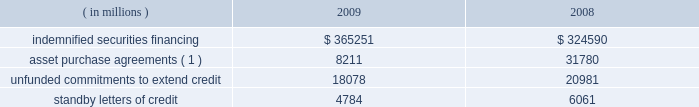Note 10 .
Commitments and contingencies credit-related commitments and contingencies : credit-related financial instruments , which are off-balance sheet , include indemnified securities financing , unfunded commitments to extend credit or purchase assets , and standby letters of credit .
The potential loss associated with indemnified securities financing , unfunded commitments and standby letters of credit is equal to the total gross contractual amount , which does not consider the value of any collateral .
The table summarizes the total gross contractual amounts of credit-related off-balance sheet financial instruments at december 31 .
Amounts reported do not reflect participations to independent third parties. .
( 1 ) amount for 2009 excludes agreements related to the commercial paper conduits , which were consolidated in may 2009 ; see note 11 .
Approximately 81% ( 81 % ) of the unfunded commitments to extend credit expire within one year from the date of issue .
Since many of these commitments are expected to expire or renew without being drawn upon , the total commitment amount does not necessarily represent future cash requirements .
Securities finance : on behalf of our customers , we lend their securities to creditworthy brokers and other institutions .
We generally indemnify our customers for the fair market value of those securities against a failure of the borrower to return such securities .
Collateral funds received in connection with our securities finance services are held by us as agent and are not recorded in our consolidated statement of condition .
We require the borrowers to provide collateral in an amount equal to or in excess of 100% ( 100 % ) of the fair market value of the securities borrowed .
The borrowed securities are revalued daily to determine if additional collateral is necessary .
In this regard , we held , as agent , cash and u.s .
Government securities with an aggregate fair value of $ 375.92 billion and $ 333.07 billion as collateral for indemnified securities on loan at december 31 , 2009 and 2008 , respectively , presented in the table above .
The collateral held by us is invested on behalf of our customers in accordance with their guidelines .
In certain cases , the collateral is invested in third-party repurchase agreements , for which we indemnify the customer against loss of the principal invested .
We require the repurchase agreement counterparty to provide collateral in an amount equal to or in excess of 100% ( 100 % ) of the amount of the repurchase agreement .
The indemnified repurchase agreements and the related collateral are not recorded in our consolidated statement of condition .
Of the collateral of $ 375.92 billion at december 31 , 2009 and $ 333.07 billion at december 31 , 2008 referenced above , $ 77.73 billion at december 31 , 2009 and $ 68.37 billion at december 31 , 2008 was invested in indemnified repurchase agreements .
We held , as agent , cash and securities with an aggregate fair value of $ 82.62 billion and $ 71.87 billion as collateral for indemnified investments in repurchase agreements at december 31 , 2009 and december 31 , 2008 , respectively .
Legal proceedings : in the ordinary course of business , we and our subsidiaries are involved in disputes , litigation and regulatory inquiries and investigations , both pending and threatened .
These matters , if resolved adversely against us , may result in monetary damages , fines and penalties or require changes in our business practices .
The resolution of these proceedings is inherently difficult to predict .
However , we do not believe that the amount of any judgment , settlement or other action arising from any pending proceeding will have a material adverse effect on our consolidated financial condition , although the outcome of certain of the matters described below may have a material adverse effect on our consolidated results of operations for the period in which such matter is resolved .
What is the percent change in the amount kept as collateral between 2008 and 2009? 
Computations: ((375.92 - 333.07) / 333.07)
Answer: 0.12865. 